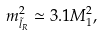Convert formula to latex. <formula><loc_0><loc_0><loc_500><loc_500>m _ { \tilde { l } _ { R } } ^ { 2 } \simeq 3 . 1 M _ { 1 } ^ { 2 } ,</formula> 